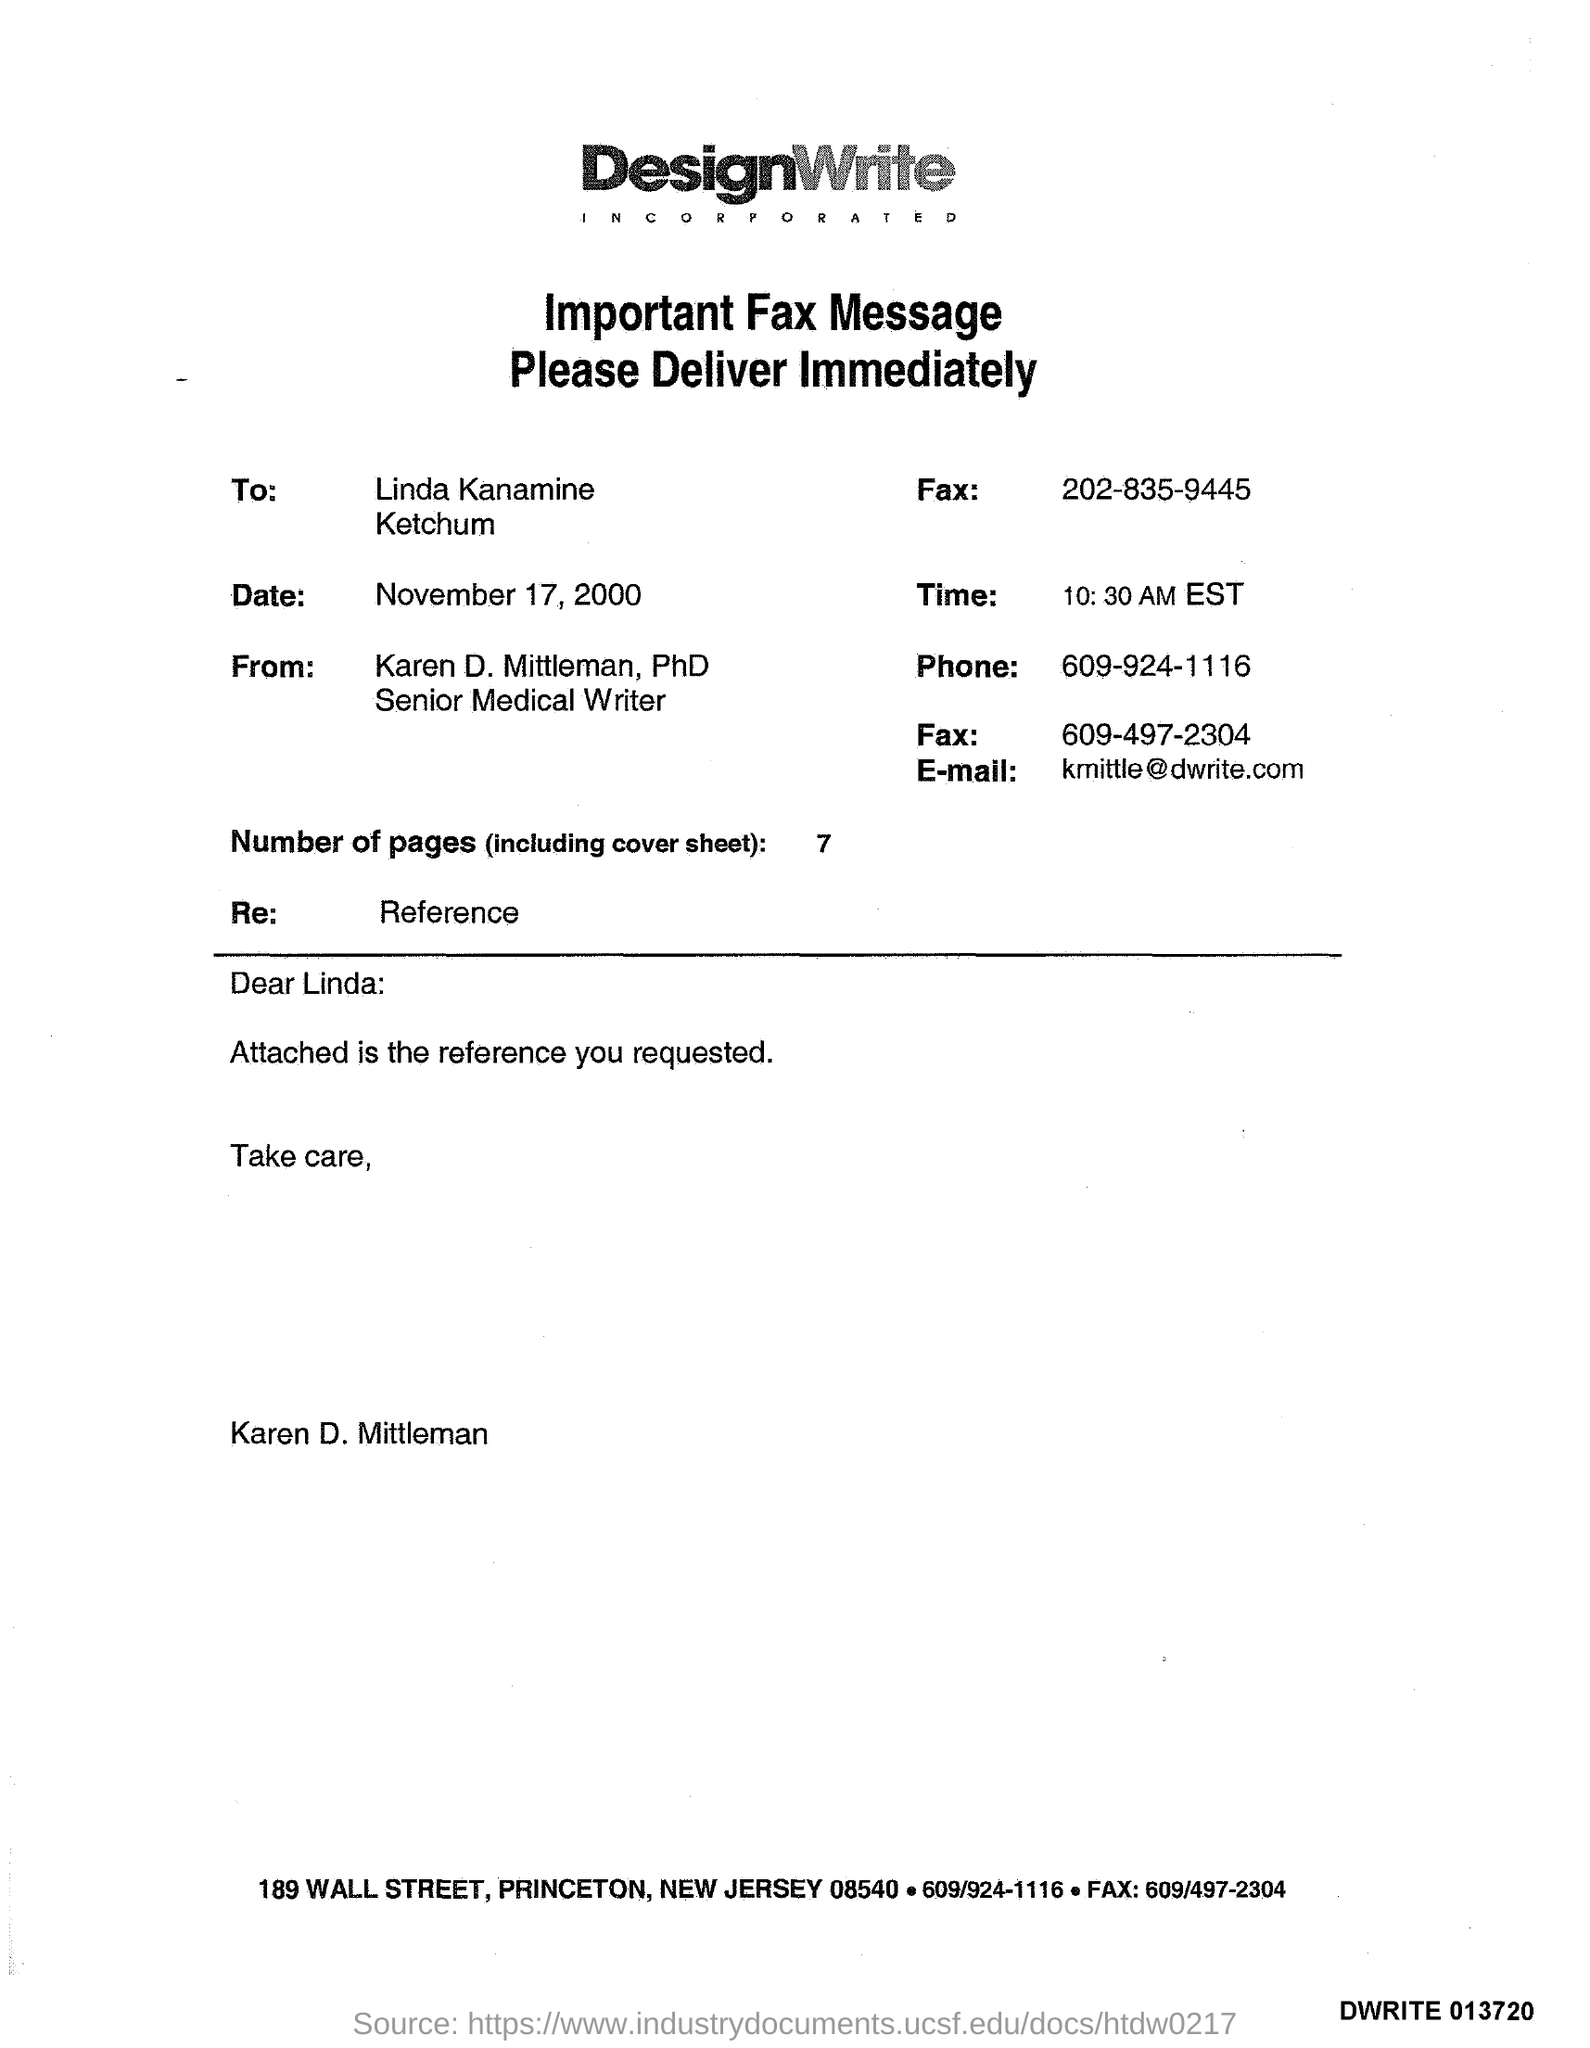What is the number of pages?
Your answer should be compact. 7. What is the time?
Ensure brevity in your answer.  10:30 AM EST. What is the E- mail address?
Ensure brevity in your answer.  Kmittle@dwrite.com. What is the phone number?
Ensure brevity in your answer.  609-924-1116. 